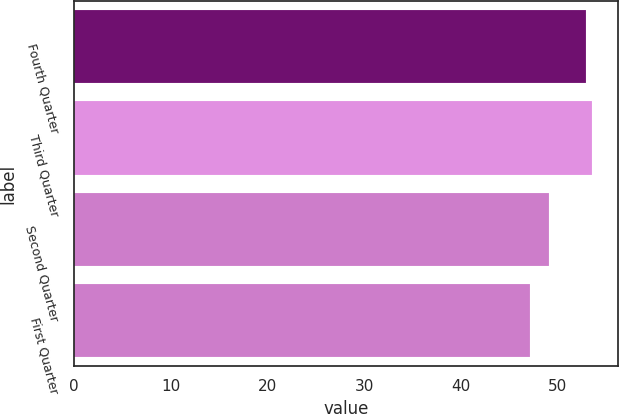Convert chart. <chart><loc_0><loc_0><loc_500><loc_500><bar_chart><fcel>Fourth Quarter<fcel>Third Quarter<fcel>Second Quarter<fcel>First Quarter<nl><fcel>52.87<fcel>53.55<fcel>49.08<fcel>47.14<nl></chart> 